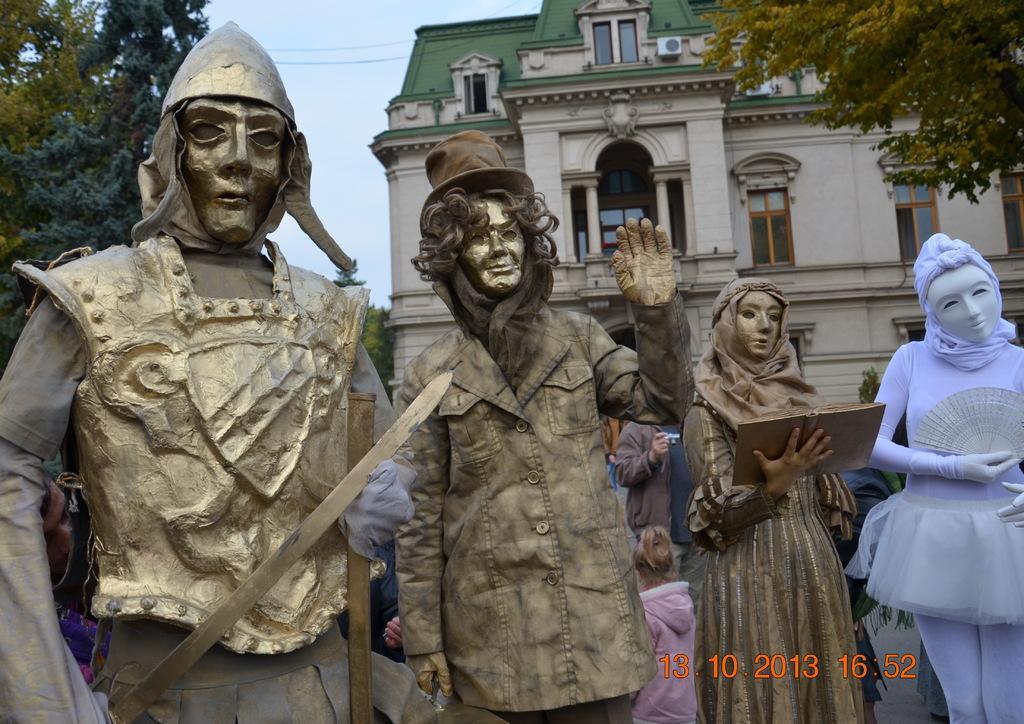Please provide a concise description of this image. In this image I can see few statues of persons which are gold, brown and purple in color. In the background I can see few persons, few trees, a building , few windows and the sky. 